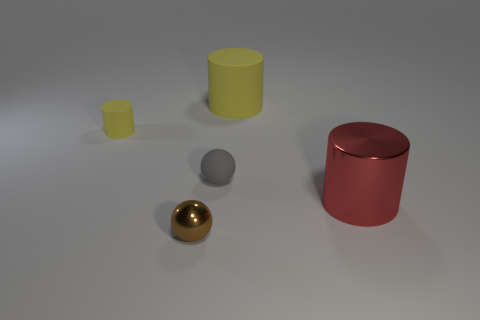Is there another tiny metal sphere that has the same color as the shiny ball? After carefully reviewing the image, there is no other sphere that matches the color of the shiny golden ball present. 